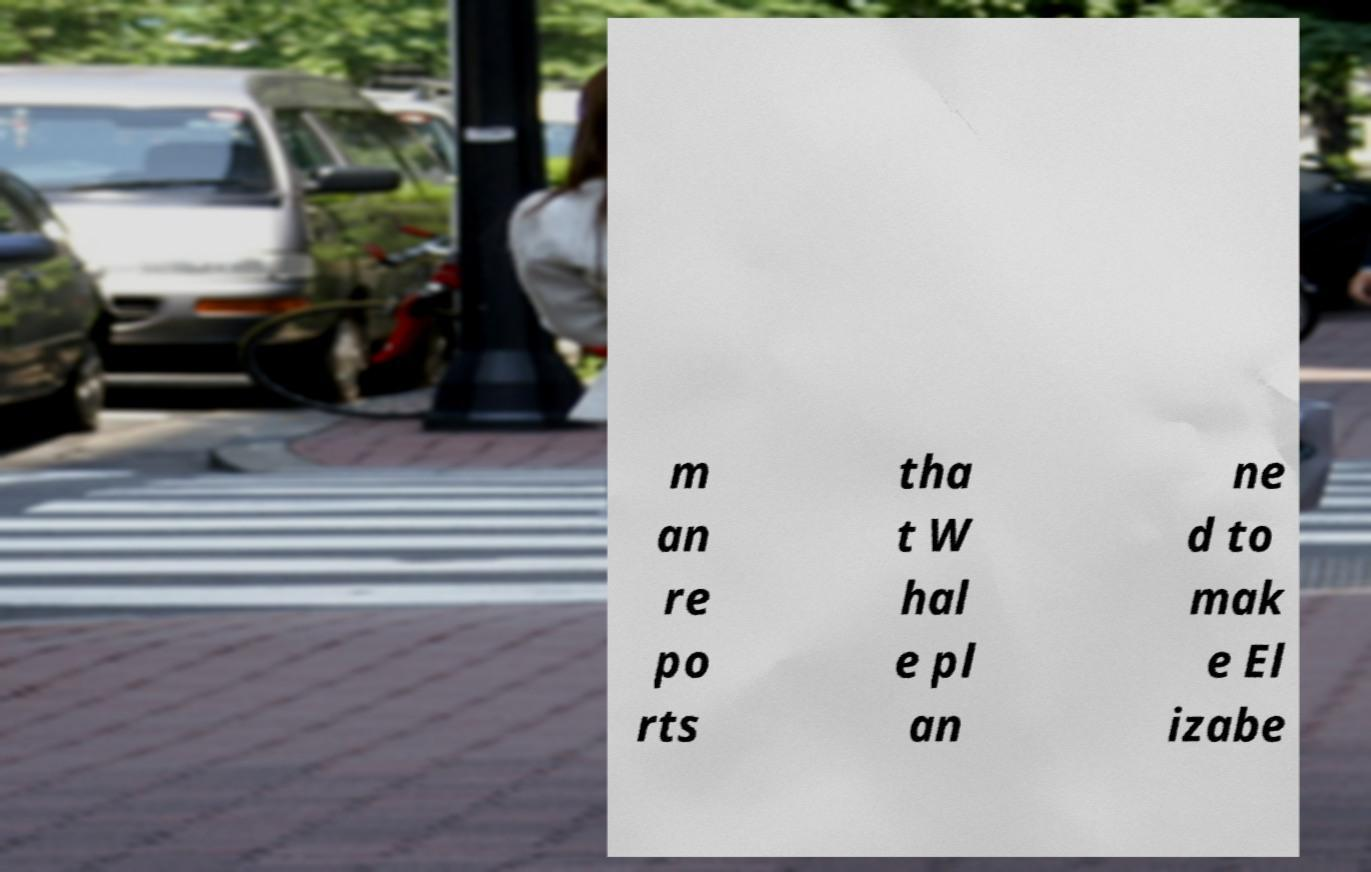Could you extract and type out the text from this image? m an re po rts tha t W hal e pl an ne d to mak e El izabe 